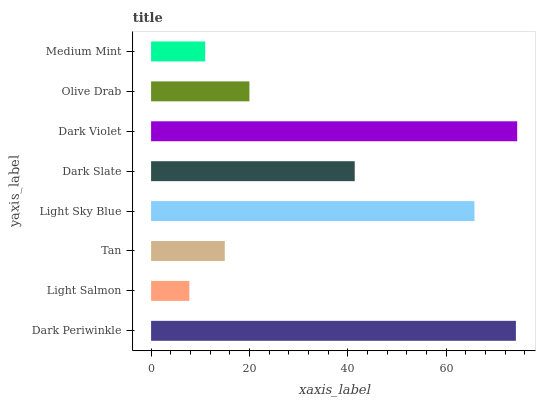Is Light Salmon the minimum?
Answer yes or no. Yes. Is Dark Violet the maximum?
Answer yes or no. Yes. Is Tan the minimum?
Answer yes or no. No. Is Tan the maximum?
Answer yes or no. No. Is Tan greater than Light Salmon?
Answer yes or no. Yes. Is Light Salmon less than Tan?
Answer yes or no. Yes. Is Light Salmon greater than Tan?
Answer yes or no. No. Is Tan less than Light Salmon?
Answer yes or no. No. Is Dark Slate the high median?
Answer yes or no. Yes. Is Olive Drab the low median?
Answer yes or no. Yes. Is Olive Drab the high median?
Answer yes or no. No. Is Dark Periwinkle the low median?
Answer yes or no. No. 